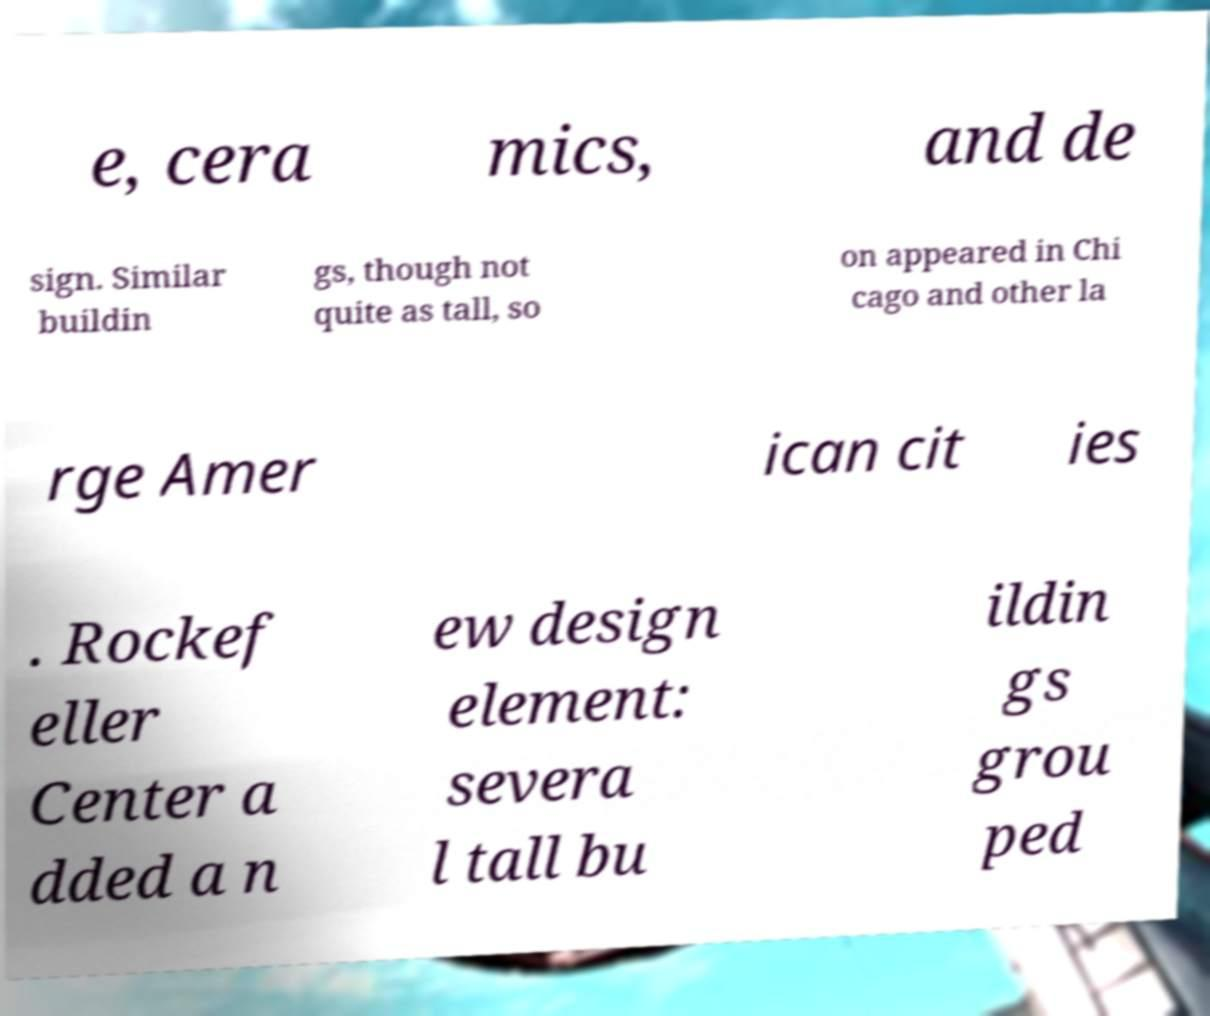Can you accurately transcribe the text from the provided image for me? e, cera mics, and de sign. Similar buildin gs, though not quite as tall, so on appeared in Chi cago and other la rge Amer ican cit ies . Rockef eller Center a dded a n ew design element: severa l tall bu ildin gs grou ped 